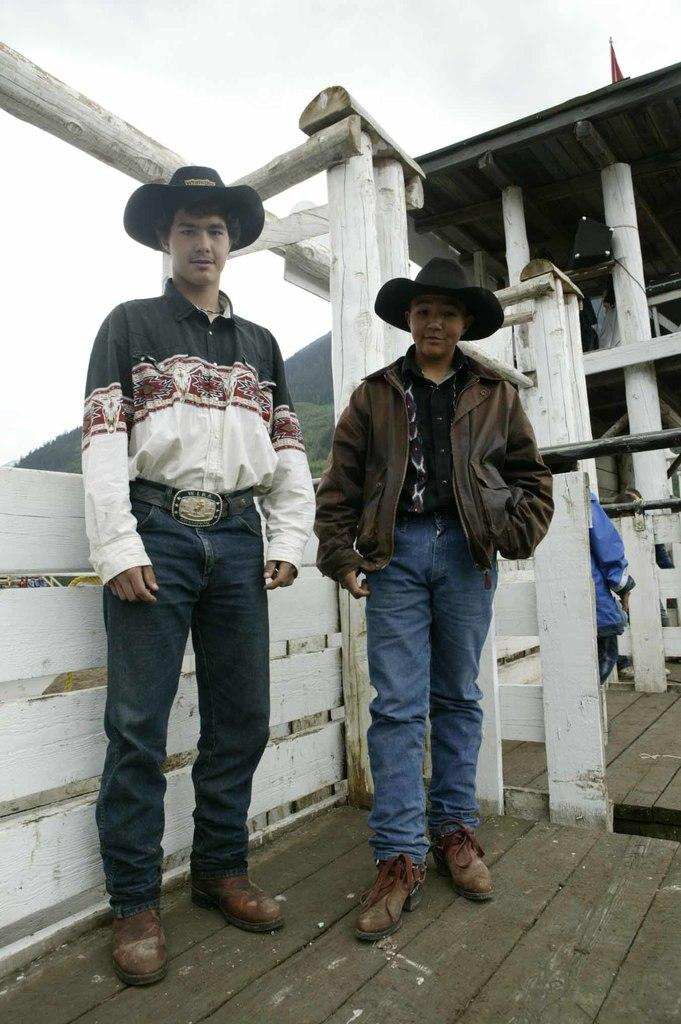How many people are present in the image? There are two men standing in the image. What is the man wearing in the image? One of the men is wearing a shirt. What can be seen in the background of the image? There are trees visible in the background of the image. What is visible above the men in the image? The sky is visible in the image. What direction are the waves coming from in the image? There are no waves present in the image. 